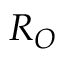Convert formula to latex. <formula><loc_0><loc_0><loc_500><loc_500>R _ { O }</formula> 